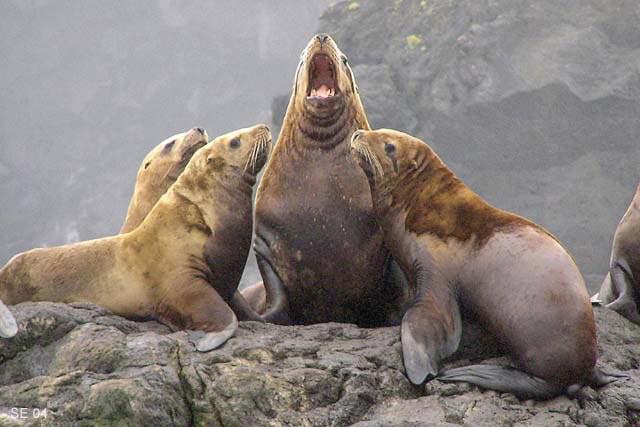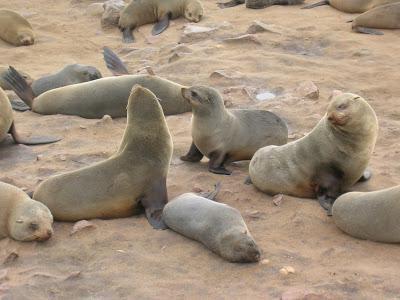The first image is the image on the left, the second image is the image on the right. Assess this claim about the two images: "An image shows just one seal in the foreground, who is facing left.". Correct or not? Answer yes or no. No. The first image is the image on the left, the second image is the image on the right. Examine the images to the left and right. Is the description "the background is hazy in the image on the left" accurate? Answer yes or no. Yes. 